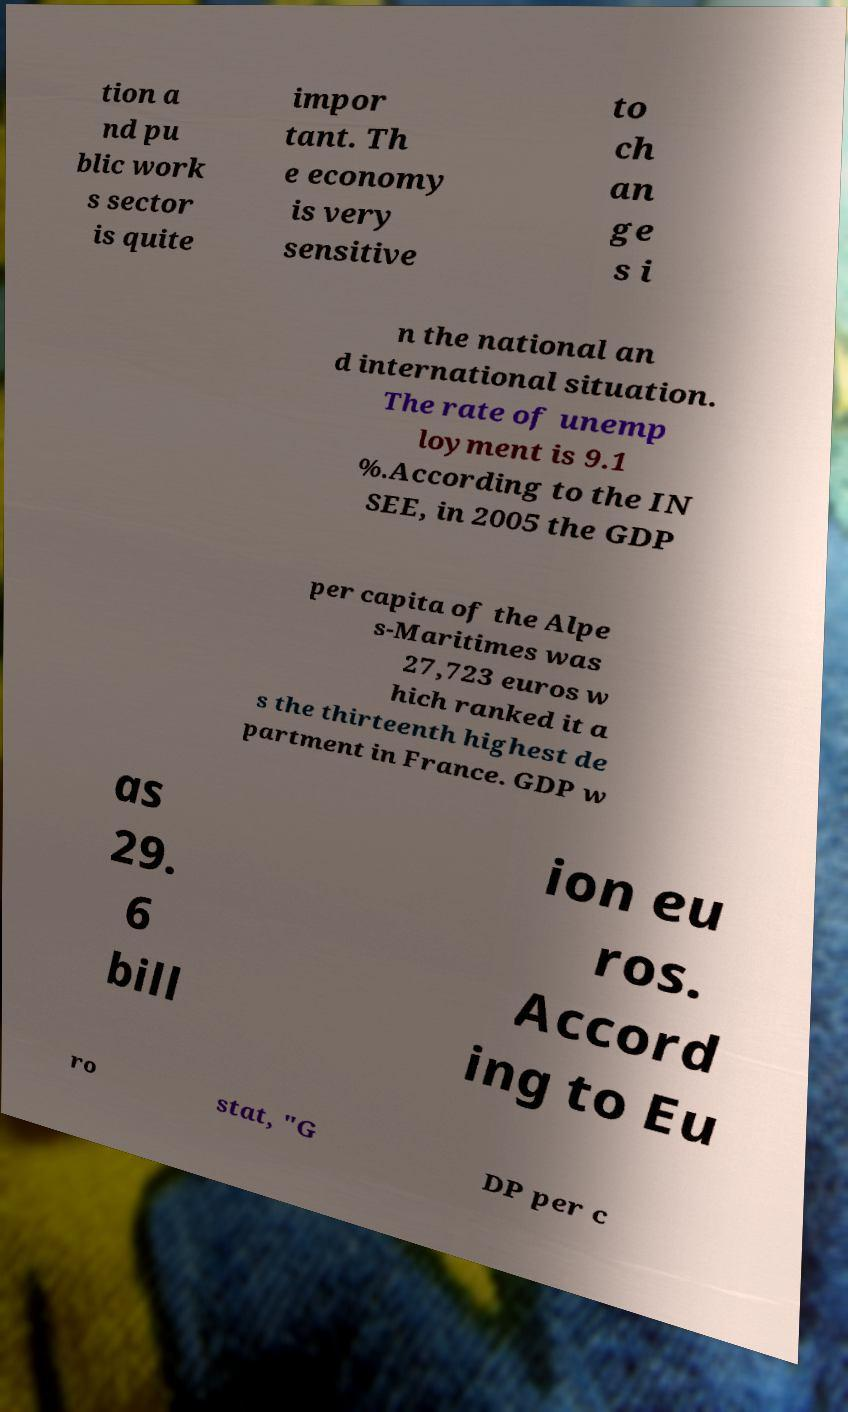Please read and relay the text visible in this image. What does it say? tion a nd pu blic work s sector is quite impor tant. Th e economy is very sensitive to ch an ge s i n the national an d international situation. The rate of unemp loyment is 9.1 %.According to the IN SEE, in 2005 the GDP per capita of the Alpe s-Maritimes was 27,723 euros w hich ranked it a s the thirteenth highest de partment in France. GDP w as 29. 6 bill ion eu ros. Accord ing to Eu ro stat, "G DP per c 